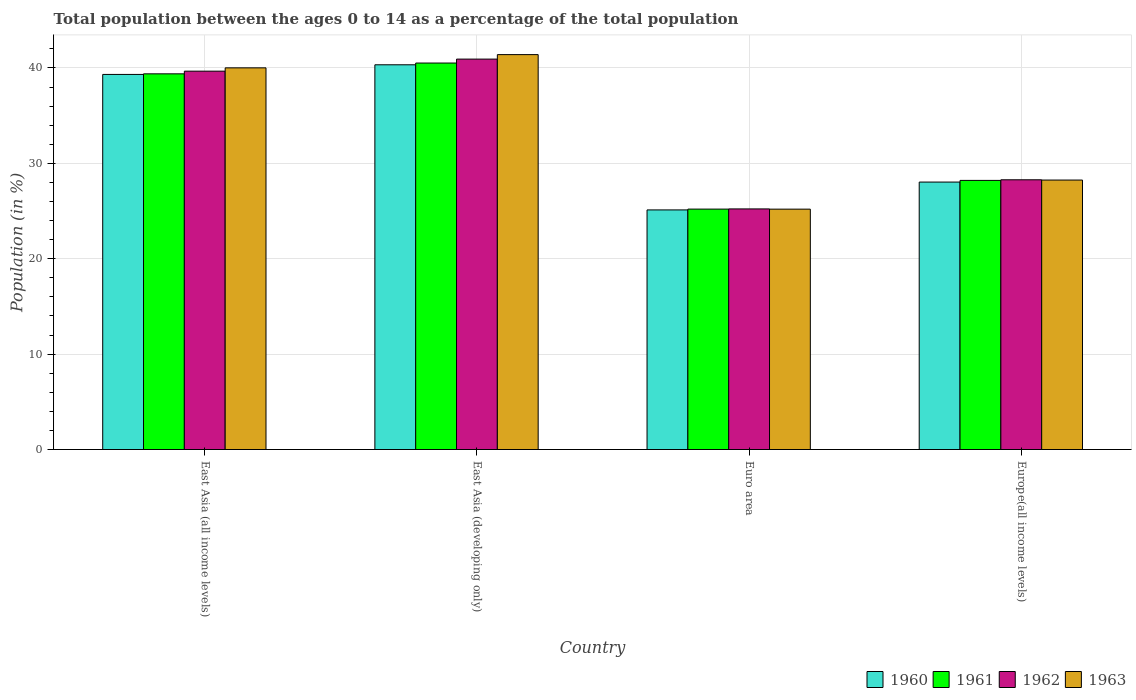Are the number of bars per tick equal to the number of legend labels?
Provide a short and direct response. Yes. Are the number of bars on each tick of the X-axis equal?
Make the answer very short. Yes. How many bars are there on the 4th tick from the right?
Your answer should be very brief. 4. What is the label of the 4th group of bars from the left?
Provide a short and direct response. Europe(all income levels). What is the percentage of the population ages 0 to 14 in 1962 in Europe(all income levels)?
Your response must be concise. 28.28. Across all countries, what is the maximum percentage of the population ages 0 to 14 in 1963?
Give a very brief answer. 41.4. Across all countries, what is the minimum percentage of the population ages 0 to 14 in 1960?
Offer a terse response. 25.12. In which country was the percentage of the population ages 0 to 14 in 1963 maximum?
Your response must be concise. East Asia (developing only). In which country was the percentage of the population ages 0 to 14 in 1960 minimum?
Provide a short and direct response. Euro area. What is the total percentage of the population ages 0 to 14 in 1960 in the graph?
Your answer should be compact. 132.81. What is the difference between the percentage of the population ages 0 to 14 in 1963 in Euro area and that in Europe(all income levels)?
Provide a succinct answer. -3.05. What is the difference between the percentage of the population ages 0 to 14 in 1963 in Europe(all income levels) and the percentage of the population ages 0 to 14 in 1961 in East Asia (all income levels)?
Offer a very short reply. -11.14. What is the average percentage of the population ages 0 to 14 in 1960 per country?
Your answer should be compact. 33.2. What is the difference between the percentage of the population ages 0 to 14 of/in 1962 and percentage of the population ages 0 to 14 of/in 1960 in Europe(all income levels)?
Give a very brief answer. 0.24. In how many countries, is the percentage of the population ages 0 to 14 in 1963 greater than 34?
Your answer should be very brief. 2. What is the ratio of the percentage of the population ages 0 to 14 in 1960 in East Asia (developing only) to that in Euro area?
Offer a very short reply. 1.61. Is the percentage of the population ages 0 to 14 in 1960 in Euro area less than that in Europe(all income levels)?
Your response must be concise. Yes. What is the difference between the highest and the second highest percentage of the population ages 0 to 14 in 1962?
Your answer should be very brief. 12.65. What is the difference between the highest and the lowest percentage of the population ages 0 to 14 in 1962?
Keep it short and to the point. 15.71. In how many countries, is the percentage of the population ages 0 to 14 in 1961 greater than the average percentage of the population ages 0 to 14 in 1961 taken over all countries?
Offer a terse response. 2. Is the sum of the percentage of the population ages 0 to 14 in 1962 in East Asia (all income levels) and East Asia (developing only) greater than the maximum percentage of the population ages 0 to 14 in 1963 across all countries?
Your answer should be very brief. Yes. Is it the case that in every country, the sum of the percentage of the population ages 0 to 14 in 1960 and percentage of the population ages 0 to 14 in 1963 is greater than the sum of percentage of the population ages 0 to 14 in 1961 and percentage of the population ages 0 to 14 in 1962?
Ensure brevity in your answer.  No. What does the 3rd bar from the right in Europe(all income levels) represents?
Make the answer very short. 1961. What is the difference between two consecutive major ticks on the Y-axis?
Provide a succinct answer. 10. Are the values on the major ticks of Y-axis written in scientific E-notation?
Ensure brevity in your answer.  No. Does the graph contain grids?
Your answer should be very brief. Yes. Where does the legend appear in the graph?
Give a very brief answer. Bottom right. What is the title of the graph?
Make the answer very short. Total population between the ages 0 to 14 as a percentage of the total population. What is the label or title of the X-axis?
Your answer should be very brief. Country. What is the label or title of the Y-axis?
Your response must be concise. Population (in %). What is the Population (in %) of 1960 in East Asia (all income levels)?
Make the answer very short. 39.32. What is the Population (in %) of 1961 in East Asia (all income levels)?
Give a very brief answer. 39.38. What is the Population (in %) of 1962 in East Asia (all income levels)?
Offer a very short reply. 39.67. What is the Population (in %) of 1963 in East Asia (all income levels)?
Make the answer very short. 40.01. What is the Population (in %) in 1960 in East Asia (developing only)?
Your response must be concise. 40.33. What is the Population (in %) in 1961 in East Asia (developing only)?
Your answer should be very brief. 40.52. What is the Population (in %) of 1962 in East Asia (developing only)?
Give a very brief answer. 40.93. What is the Population (in %) in 1963 in East Asia (developing only)?
Your answer should be very brief. 41.4. What is the Population (in %) in 1960 in Euro area?
Provide a succinct answer. 25.12. What is the Population (in %) in 1961 in Euro area?
Your response must be concise. 25.2. What is the Population (in %) of 1962 in Euro area?
Ensure brevity in your answer.  25.22. What is the Population (in %) of 1963 in Euro area?
Give a very brief answer. 25.2. What is the Population (in %) of 1960 in Europe(all income levels)?
Provide a succinct answer. 28.04. What is the Population (in %) of 1961 in Europe(all income levels)?
Offer a terse response. 28.21. What is the Population (in %) of 1962 in Europe(all income levels)?
Make the answer very short. 28.28. What is the Population (in %) of 1963 in Europe(all income levels)?
Give a very brief answer. 28.25. Across all countries, what is the maximum Population (in %) of 1960?
Give a very brief answer. 40.33. Across all countries, what is the maximum Population (in %) of 1961?
Your answer should be compact. 40.52. Across all countries, what is the maximum Population (in %) in 1962?
Your answer should be compact. 40.93. Across all countries, what is the maximum Population (in %) of 1963?
Your answer should be very brief. 41.4. Across all countries, what is the minimum Population (in %) of 1960?
Give a very brief answer. 25.12. Across all countries, what is the minimum Population (in %) in 1961?
Provide a succinct answer. 25.2. Across all countries, what is the minimum Population (in %) in 1962?
Provide a short and direct response. 25.22. Across all countries, what is the minimum Population (in %) in 1963?
Offer a very short reply. 25.2. What is the total Population (in %) in 1960 in the graph?
Make the answer very short. 132.81. What is the total Population (in %) in 1961 in the graph?
Offer a terse response. 133.32. What is the total Population (in %) in 1962 in the graph?
Offer a very short reply. 134.1. What is the total Population (in %) in 1963 in the graph?
Provide a succinct answer. 134.86. What is the difference between the Population (in %) in 1960 in East Asia (all income levels) and that in East Asia (developing only)?
Provide a succinct answer. -1.01. What is the difference between the Population (in %) of 1961 in East Asia (all income levels) and that in East Asia (developing only)?
Your response must be concise. -1.13. What is the difference between the Population (in %) in 1962 in East Asia (all income levels) and that in East Asia (developing only)?
Provide a succinct answer. -1.26. What is the difference between the Population (in %) of 1963 in East Asia (all income levels) and that in East Asia (developing only)?
Your response must be concise. -1.39. What is the difference between the Population (in %) in 1960 in East Asia (all income levels) and that in Euro area?
Keep it short and to the point. 14.2. What is the difference between the Population (in %) in 1961 in East Asia (all income levels) and that in Euro area?
Offer a very short reply. 14.18. What is the difference between the Population (in %) in 1962 in East Asia (all income levels) and that in Euro area?
Give a very brief answer. 14.44. What is the difference between the Population (in %) of 1963 in East Asia (all income levels) and that in Euro area?
Your answer should be very brief. 14.81. What is the difference between the Population (in %) of 1960 in East Asia (all income levels) and that in Europe(all income levels)?
Your answer should be very brief. 11.28. What is the difference between the Population (in %) of 1961 in East Asia (all income levels) and that in Europe(all income levels)?
Ensure brevity in your answer.  11.17. What is the difference between the Population (in %) in 1962 in East Asia (all income levels) and that in Europe(all income levels)?
Keep it short and to the point. 11.39. What is the difference between the Population (in %) of 1963 in East Asia (all income levels) and that in Europe(all income levels)?
Your answer should be very brief. 11.76. What is the difference between the Population (in %) of 1960 in East Asia (developing only) and that in Euro area?
Your response must be concise. 15.21. What is the difference between the Population (in %) in 1961 in East Asia (developing only) and that in Euro area?
Your answer should be very brief. 15.31. What is the difference between the Population (in %) in 1962 in East Asia (developing only) and that in Euro area?
Ensure brevity in your answer.  15.71. What is the difference between the Population (in %) of 1963 in East Asia (developing only) and that in Euro area?
Provide a short and direct response. 16.2. What is the difference between the Population (in %) in 1960 in East Asia (developing only) and that in Europe(all income levels)?
Keep it short and to the point. 12.29. What is the difference between the Population (in %) in 1961 in East Asia (developing only) and that in Europe(all income levels)?
Your answer should be very brief. 12.3. What is the difference between the Population (in %) of 1962 in East Asia (developing only) and that in Europe(all income levels)?
Keep it short and to the point. 12.65. What is the difference between the Population (in %) of 1963 in East Asia (developing only) and that in Europe(all income levels)?
Provide a succinct answer. 13.15. What is the difference between the Population (in %) in 1960 in Euro area and that in Europe(all income levels)?
Your answer should be compact. -2.92. What is the difference between the Population (in %) in 1961 in Euro area and that in Europe(all income levels)?
Your answer should be very brief. -3.01. What is the difference between the Population (in %) in 1962 in Euro area and that in Europe(all income levels)?
Your answer should be compact. -3.05. What is the difference between the Population (in %) in 1963 in Euro area and that in Europe(all income levels)?
Offer a terse response. -3.05. What is the difference between the Population (in %) in 1960 in East Asia (all income levels) and the Population (in %) in 1961 in East Asia (developing only)?
Offer a terse response. -1.2. What is the difference between the Population (in %) of 1960 in East Asia (all income levels) and the Population (in %) of 1962 in East Asia (developing only)?
Provide a succinct answer. -1.61. What is the difference between the Population (in %) in 1960 in East Asia (all income levels) and the Population (in %) in 1963 in East Asia (developing only)?
Your response must be concise. -2.08. What is the difference between the Population (in %) of 1961 in East Asia (all income levels) and the Population (in %) of 1962 in East Asia (developing only)?
Make the answer very short. -1.54. What is the difference between the Population (in %) of 1961 in East Asia (all income levels) and the Population (in %) of 1963 in East Asia (developing only)?
Your answer should be very brief. -2.02. What is the difference between the Population (in %) in 1962 in East Asia (all income levels) and the Population (in %) in 1963 in East Asia (developing only)?
Offer a very short reply. -1.73. What is the difference between the Population (in %) of 1960 in East Asia (all income levels) and the Population (in %) of 1961 in Euro area?
Give a very brief answer. 14.12. What is the difference between the Population (in %) of 1960 in East Asia (all income levels) and the Population (in %) of 1962 in Euro area?
Offer a very short reply. 14.1. What is the difference between the Population (in %) of 1960 in East Asia (all income levels) and the Population (in %) of 1963 in Euro area?
Make the answer very short. 14.12. What is the difference between the Population (in %) in 1961 in East Asia (all income levels) and the Population (in %) in 1962 in Euro area?
Ensure brevity in your answer.  14.16. What is the difference between the Population (in %) in 1961 in East Asia (all income levels) and the Population (in %) in 1963 in Euro area?
Provide a succinct answer. 14.19. What is the difference between the Population (in %) of 1962 in East Asia (all income levels) and the Population (in %) of 1963 in Euro area?
Keep it short and to the point. 14.47. What is the difference between the Population (in %) in 1960 in East Asia (all income levels) and the Population (in %) in 1961 in Europe(all income levels)?
Offer a terse response. 11.11. What is the difference between the Population (in %) in 1960 in East Asia (all income levels) and the Population (in %) in 1962 in Europe(all income levels)?
Ensure brevity in your answer.  11.04. What is the difference between the Population (in %) of 1960 in East Asia (all income levels) and the Population (in %) of 1963 in Europe(all income levels)?
Give a very brief answer. 11.07. What is the difference between the Population (in %) in 1961 in East Asia (all income levels) and the Population (in %) in 1962 in Europe(all income levels)?
Your answer should be very brief. 11.11. What is the difference between the Population (in %) of 1961 in East Asia (all income levels) and the Population (in %) of 1963 in Europe(all income levels)?
Your answer should be compact. 11.14. What is the difference between the Population (in %) in 1962 in East Asia (all income levels) and the Population (in %) in 1963 in Europe(all income levels)?
Offer a terse response. 11.42. What is the difference between the Population (in %) of 1960 in East Asia (developing only) and the Population (in %) of 1961 in Euro area?
Provide a short and direct response. 15.13. What is the difference between the Population (in %) in 1960 in East Asia (developing only) and the Population (in %) in 1962 in Euro area?
Make the answer very short. 15.11. What is the difference between the Population (in %) of 1960 in East Asia (developing only) and the Population (in %) of 1963 in Euro area?
Make the answer very short. 15.13. What is the difference between the Population (in %) in 1961 in East Asia (developing only) and the Population (in %) in 1962 in Euro area?
Your answer should be compact. 15.29. What is the difference between the Population (in %) in 1961 in East Asia (developing only) and the Population (in %) in 1963 in Euro area?
Offer a terse response. 15.32. What is the difference between the Population (in %) in 1962 in East Asia (developing only) and the Population (in %) in 1963 in Euro area?
Provide a succinct answer. 15.73. What is the difference between the Population (in %) of 1960 in East Asia (developing only) and the Population (in %) of 1961 in Europe(all income levels)?
Keep it short and to the point. 12.12. What is the difference between the Population (in %) of 1960 in East Asia (developing only) and the Population (in %) of 1962 in Europe(all income levels)?
Offer a terse response. 12.06. What is the difference between the Population (in %) of 1960 in East Asia (developing only) and the Population (in %) of 1963 in Europe(all income levels)?
Your answer should be very brief. 12.08. What is the difference between the Population (in %) in 1961 in East Asia (developing only) and the Population (in %) in 1962 in Europe(all income levels)?
Keep it short and to the point. 12.24. What is the difference between the Population (in %) of 1961 in East Asia (developing only) and the Population (in %) of 1963 in Europe(all income levels)?
Your answer should be compact. 12.27. What is the difference between the Population (in %) in 1962 in East Asia (developing only) and the Population (in %) in 1963 in Europe(all income levels)?
Your response must be concise. 12.68. What is the difference between the Population (in %) of 1960 in Euro area and the Population (in %) of 1961 in Europe(all income levels)?
Provide a succinct answer. -3.1. What is the difference between the Population (in %) in 1960 in Euro area and the Population (in %) in 1962 in Europe(all income levels)?
Offer a terse response. -3.16. What is the difference between the Population (in %) in 1960 in Euro area and the Population (in %) in 1963 in Europe(all income levels)?
Provide a succinct answer. -3.13. What is the difference between the Population (in %) of 1961 in Euro area and the Population (in %) of 1962 in Europe(all income levels)?
Give a very brief answer. -3.07. What is the difference between the Population (in %) of 1961 in Euro area and the Population (in %) of 1963 in Europe(all income levels)?
Your answer should be very brief. -3.04. What is the difference between the Population (in %) of 1962 in Euro area and the Population (in %) of 1963 in Europe(all income levels)?
Your answer should be compact. -3.03. What is the average Population (in %) in 1960 per country?
Your response must be concise. 33.2. What is the average Population (in %) of 1961 per country?
Provide a succinct answer. 33.33. What is the average Population (in %) of 1962 per country?
Keep it short and to the point. 33.52. What is the average Population (in %) of 1963 per country?
Offer a very short reply. 33.71. What is the difference between the Population (in %) of 1960 and Population (in %) of 1961 in East Asia (all income levels)?
Provide a succinct answer. -0.06. What is the difference between the Population (in %) of 1960 and Population (in %) of 1962 in East Asia (all income levels)?
Your answer should be compact. -0.34. What is the difference between the Population (in %) in 1960 and Population (in %) in 1963 in East Asia (all income levels)?
Your answer should be compact. -0.69. What is the difference between the Population (in %) of 1961 and Population (in %) of 1962 in East Asia (all income levels)?
Provide a short and direct response. -0.28. What is the difference between the Population (in %) of 1961 and Population (in %) of 1963 in East Asia (all income levels)?
Provide a succinct answer. -0.63. What is the difference between the Population (in %) of 1962 and Population (in %) of 1963 in East Asia (all income levels)?
Your answer should be very brief. -0.35. What is the difference between the Population (in %) of 1960 and Population (in %) of 1961 in East Asia (developing only)?
Offer a very short reply. -0.18. What is the difference between the Population (in %) of 1960 and Population (in %) of 1962 in East Asia (developing only)?
Your answer should be compact. -0.6. What is the difference between the Population (in %) of 1960 and Population (in %) of 1963 in East Asia (developing only)?
Give a very brief answer. -1.07. What is the difference between the Population (in %) of 1961 and Population (in %) of 1962 in East Asia (developing only)?
Keep it short and to the point. -0.41. What is the difference between the Population (in %) of 1961 and Population (in %) of 1963 in East Asia (developing only)?
Your answer should be compact. -0.88. What is the difference between the Population (in %) in 1962 and Population (in %) in 1963 in East Asia (developing only)?
Provide a succinct answer. -0.47. What is the difference between the Population (in %) of 1960 and Population (in %) of 1961 in Euro area?
Offer a terse response. -0.09. What is the difference between the Population (in %) in 1960 and Population (in %) in 1962 in Euro area?
Make the answer very short. -0.1. What is the difference between the Population (in %) of 1960 and Population (in %) of 1963 in Euro area?
Keep it short and to the point. -0.08. What is the difference between the Population (in %) in 1961 and Population (in %) in 1962 in Euro area?
Keep it short and to the point. -0.02. What is the difference between the Population (in %) of 1961 and Population (in %) of 1963 in Euro area?
Provide a short and direct response. 0. What is the difference between the Population (in %) in 1962 and Population (in %) in 1963 in Euro area?
Your answer should be very brief. 0.02. What is the difference between the Population (in %) of 1960 and Population (in %) of 1961 in Europe(all income levels)?
Make the answer very short. -0.18. What is the difference between the Population (in %) of 1960 and Population (in %) of 1962 in Europe(all income levels)?
Ensure brevity in your answer.  -0.24. What is the difference between the Population (in %) of 1960 and Population (in %) of 1963 in Europe(all income levels)?
Provide a succinct answer. -0.21. What is the difference between the Population (in %) in 1961 and Population (in %) in 1962 in Europe(all income levels)?
Offer a very short reply. -0.06. What is the difference between the Population (in %) in 1961 and Population (in %) in 1963 in Europe(all income levels)?
Your answer should be compact. -0.04. What is the difference between the Population (in %) in 1962 and Population (in %) in 1963 in Europe(all income levels)?
Make the answer very short. 0.03. What is the ratio of the Population (in %) of 1961 in East Asia (all income levels) to that in East Asia (developing only)?
Offer a terse response. 0.97. What is the ratio of the Population (in %) of 1962 in East Asia (all income levels) to that in East Asia (developing only)?
Provide a succinct answer. 0.97. What is the ratio of the Population (in %) in 1963 in East Asia (all income levels) to that in East Asia (developing only)?
Make the answer very short. 0.97. What is the ratio of the Population (in %) of 1960 in East Asia (all income levels) to that in Euro area?
Your answer should be compact. 1.57. What is the ratio of the Population (in %) of 1961 in East Asia (all income levels) to that in Euro area?
Make the answer very short. 1.56. What is the ratio of the Population (in %) of 1962 in East Asia (all income levels) to that in Euro area?
Offer a terse response. 1.57. What is the ratio of the Population (in %) of 1963 in East Asia (all income levels) to that in Euro area?
Your answer should be very brief. 1.59. What is the ratio of the Population (in %) of 1960 in East Asia (all income levels) to that in Europe(all income levels)?
Make the answer very short. 1.4. What is the ratio of the Population (in %) in 1961 in East Asia (all income levels) to that in Europe(all income levels)?
Your answer should be very brief. 1.4. What is the ratio of the Population (in %) in 1962 in East Asia (all income levels) to that in Europe(all income levels)?
Offer a very short reply. 1.4. What is the ratio of the Population (in %) of 1963 in East Asia (all income levels) to that in Europe(all income levels)?
Your response must be concise. 1.42. What is the ratio of the Population (in %) of 1960 in East Asia (developing only) to that in Euro area?
Your answer should be compact. 1.61. What is the ratio of the Population (in %) of 1961 in East Asia (developing only) to that in Euro area?
Ensure brevity in your answer.  1.61. What is the ratio of the Population (in %) of 1962 in East Asia (developing only) to that in Euro area?
Make the answer very short. 1.62. What is the ratio of the Population (in %) of 1963 in East Asia (developing only) to that in Euro area?
Your answer should be very brief. 1.64. What is the ratio of the Population (in %) in 1960 in East Asia (developing only) to that in Europe(all income levels)?
Your answer should be compact. 1.44. What is the ratio of the Population (in %) in 1961 in East Asia (developing only) to that in Europe(all income levels)?
Your answer should be compact. 1.44. What is the ratio of the Population (in %) in 1962 in East Asia (developing only) to that in Europe(all income levels)?
Keep it short and to the point. 1.45. What is the ratio of the Population (in %) of 1963 in East Asia (developing only) to that in Europe(all income levels)?
Make the answer very short. 1.47. What is the ratio of the Population (in %) of 1960 in Euro area to that in Europe(all income levels)?
Offer a terse response. 0.9. What is the ratio of the Population (in %) of 1961 in Euro area to that in Europe(all income levels)?
Give a very brief answer. 0.89. What is the ratio of the Population (in %) in 1962 in Euro area to that in Europe(all income levels)?
Offer a terse response. 0.89. What is the ratio of the Population (in %) of 1963 in Euro area to that in Europe(all income levels)?
Provide a succinct answer. 0.89. What is the difference between the highest and the second highest Population (in %) in 1960?
Your response must be concise. 1.01. What is the difference between the highest and the second highest Population (in %) in 1961?
Offer a very short reply. 1.13. What is the difference between the highest and the second highest Population (in %) of 1962?
Offer a terse response. 1.26. What is the difference between the highest and the second highest Population (in %) of 1963?
Ensure brevity in your answer.  1.39. What is the difference between the highest and the lowest Population (in %) in 1960?
Your answer should be very brief. 15.21. What is the difference between the highest and the lowest Population (in %) in 1961?
Ensure brevity in your answer.  15.31. What is the difference between the highest and the lowest Population (in %) of 1962?
Offer a very short reply. 15.71. What is the difference between the highest and the lowest Population (in %) of 1963?
Offer a very short reply. 16.2. 